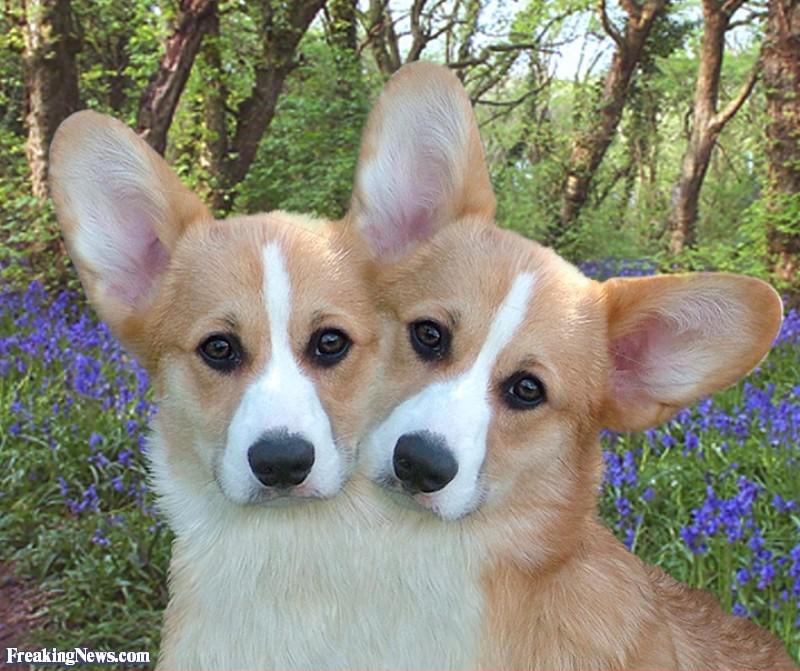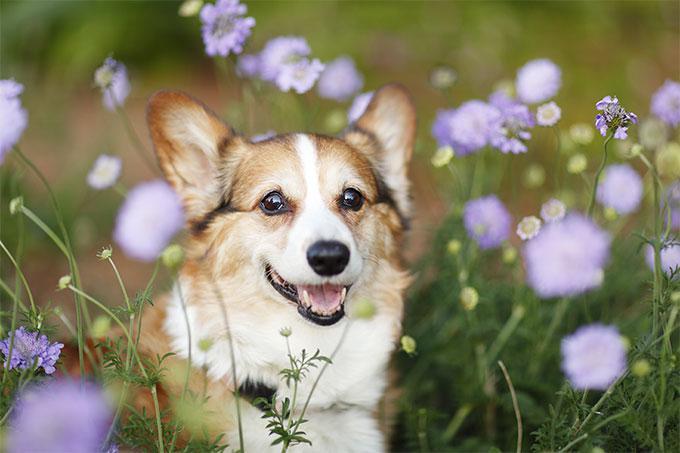The first image is the image on the left, the second image is the image on the right. For the images displayed, is the sentence "One of the dogs is standing on all four on the grass." factually correct? Answer yes or no. No. The first image is the image on the left, the second image is the image on the right. Assess this claim about the two images: "An image shows two big-eared dog faces slide-by-side.". Correct or not? Answer yes or no. Yes. 